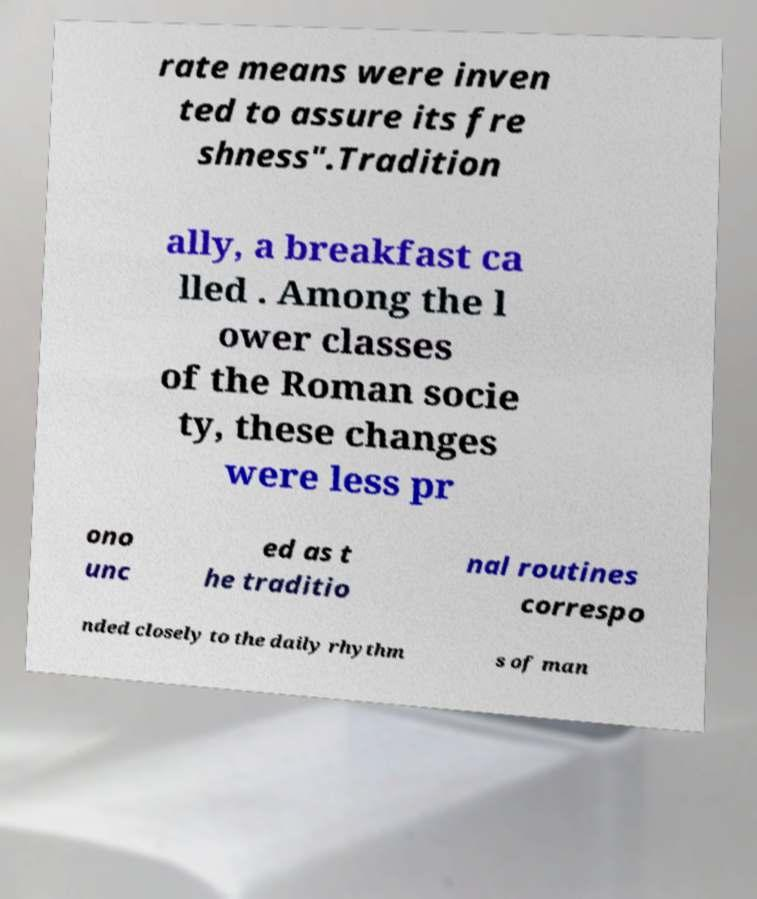Can you read and provide the text displayed in the image?This photo seems to have some interesting text. Can you extract and type it out for me? rate means were inven ted to assure its fre shness".Tradition ally, a breakfast ca lled . Among the l ower classes of the Roman socie ty, these changes were less pr ono unc ed as t he traditio nal routines correspo nded closely to the daily rhythm s of man 